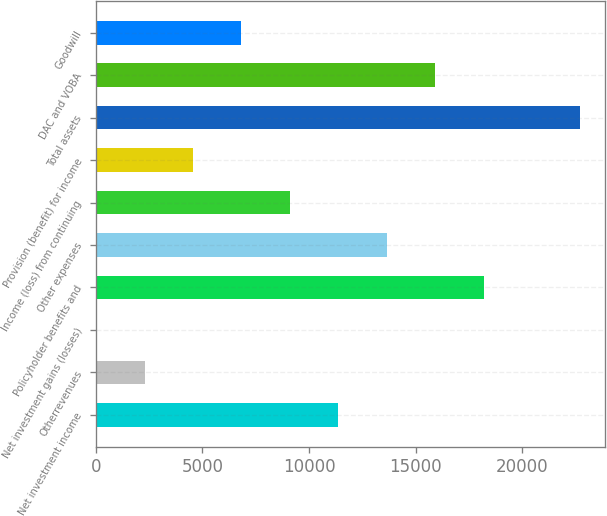<chart> <loc_0><loc_0><loc_500><loc_500><bar_chart><fcel>Net investment income<fcel>Otherrevenues<fcel>Net investment gains (losses)<fcel>Policyholder benefits and<fcel>Other expenses<fcel>Income (loss) from continuing<fcel>Provision (benefit) for income<fcel>Total assets<fcel>DAC and VOBA<fcel>Goodwill<nl><fcel>11373<fcel>2292.2<fcel>22<fcel>18183.6<fcel>13643.2<fcel>9102.8<fcel>4562.4<fcel>22724<fcel>15913.4<fcel>6832.6<nl></chart> 